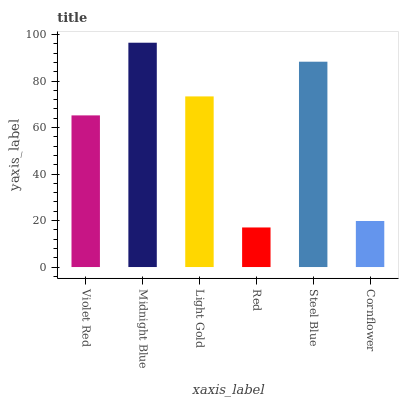Is Light Gold the minimum?
Answer yes or no. No. Is Light Gold the maximum?
Answer yes or no. No. Is Midnight Blue greater than Light Gold?
Answer yes or no. Yes. Is Light Gold less than Midnight Blue?
Answer yes or no. Yes. Is Light Gold greater than Midnight Blue?
Answer yes or no. No. Is Midnight Blue less than Light Gold?
Answer yes or no. No. Is Light Gold the high median?
Answer yes or no. Yes. Is Violet Red the low median?
Answer yes or no. Yes. Is Midnight Blue the high median?
Answer yes or no. No. Is Midnight Blue the low median?
Answer yes or no. No. 